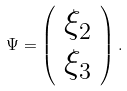Convert formula to latex. <formula><loc_0><loc_0><loc_500><loc_500>\Psi = \left ( \begin{array} { c c } \xi _ { 2 } \\ \xi _ { 3 } \end{array} \right ) .</formula> 